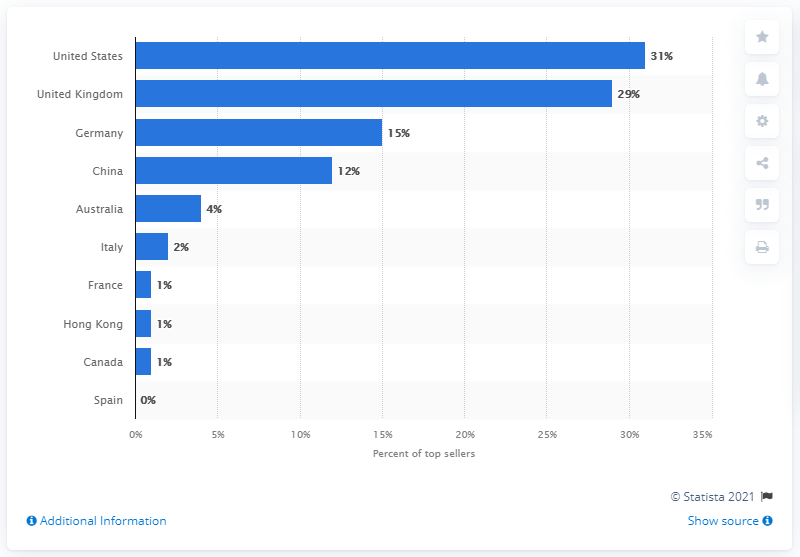Draw attention to some important aspects in this diagram. A significant percentage of top sellers were discovered in the United Kingdom. Germany had 15% of the top sellers in the country. 